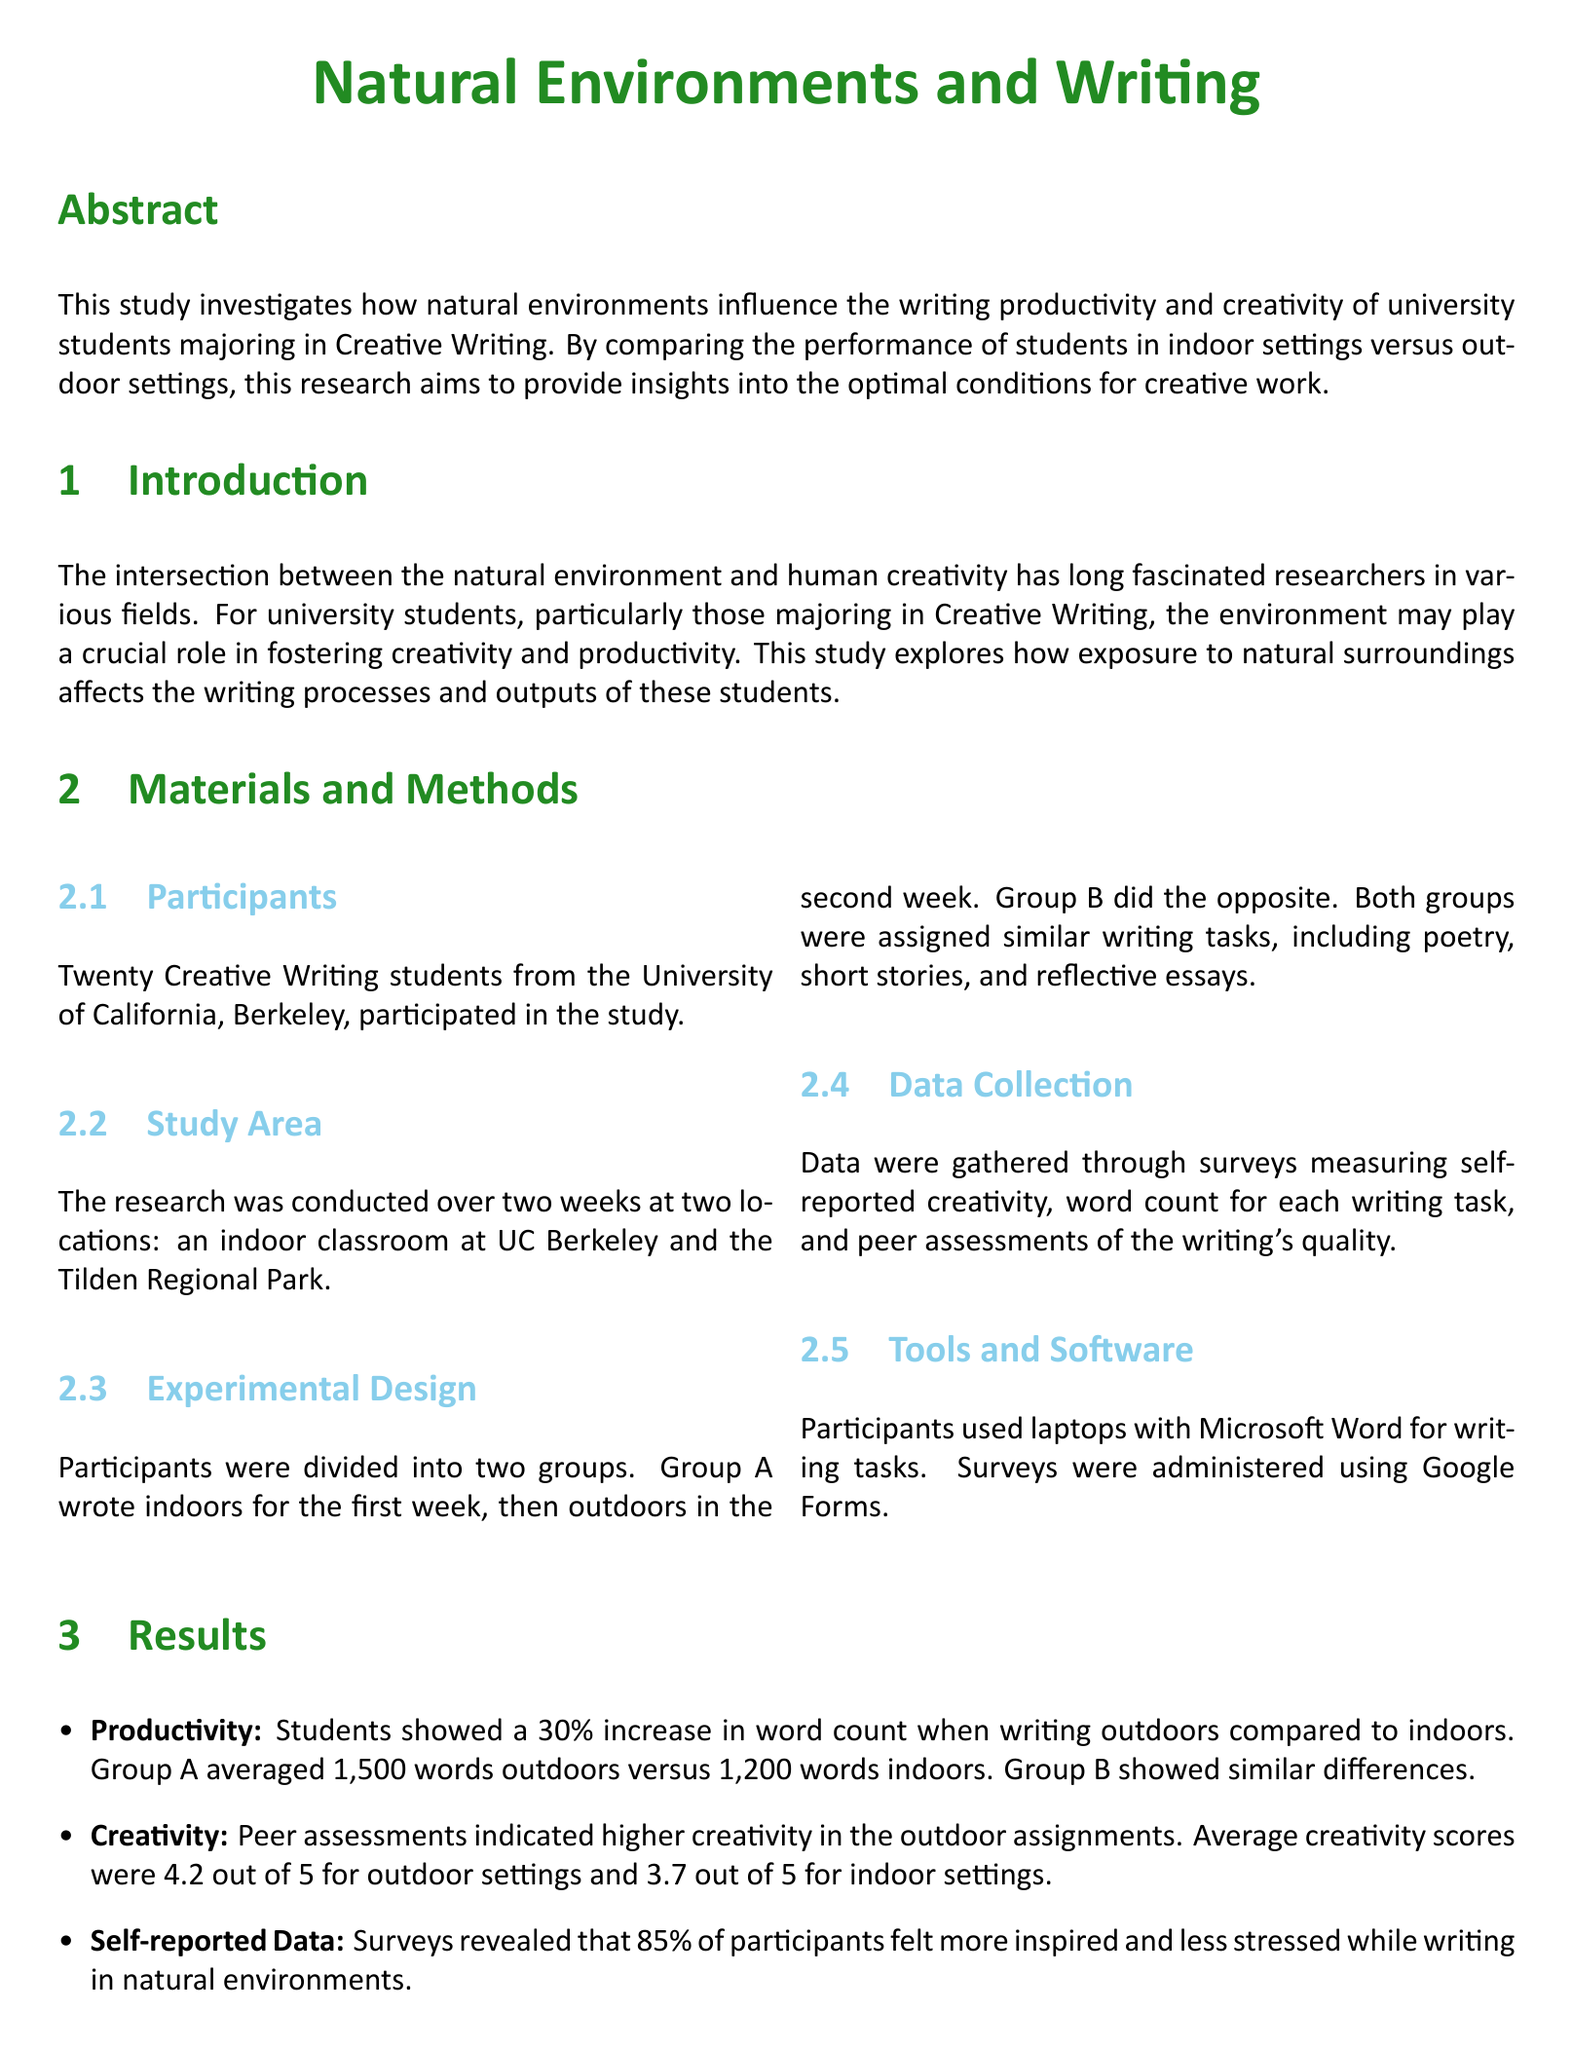What is the main focus of the study? The study's main focus is on how natural environments influence writing productivity and creativity of university students majoring in Creative Writing.
Answer: writing productivity and creativity How many students participated in the study? The number of students who participated in the study is specified in the document.
Answer: twenty What locations were used for the study? The document lists the locations where the study was conducted, which include an indoor classroom and an outdoor park.
Answer: indoor classroom and Tilden Regional Park What was the increase in word count when writing outdoors? The increase in word count is quantified in the results section, showing a specific percentage increase.
Answer: 30 percent What was the average creativity score for outdoor assignments? The average creativity score for outdoor assignments is mentioned, indicating the participants' assessment of creativity.
Answer: 4.2 out of 5 What percentage of participants felt inspired while writing outdoors? The document provides a specific percentage of participants who reported feeling inspired in natural environments.
Answer: 85 percent What conclusion does the study draw about natural environments? The conclusion summarizes the impact of natural environments on the writing process, as indicated in the document.
Answer: positive impact What tool was used for data collection through surveys? The document specifies the software used by participants for administering surveys during the study.
Answer: Google Forms What is one suggestion for future research mentioned in the study? The study proposes an area for future exploration regarding the effects of different environmental settings.
Answer: long-term effects 